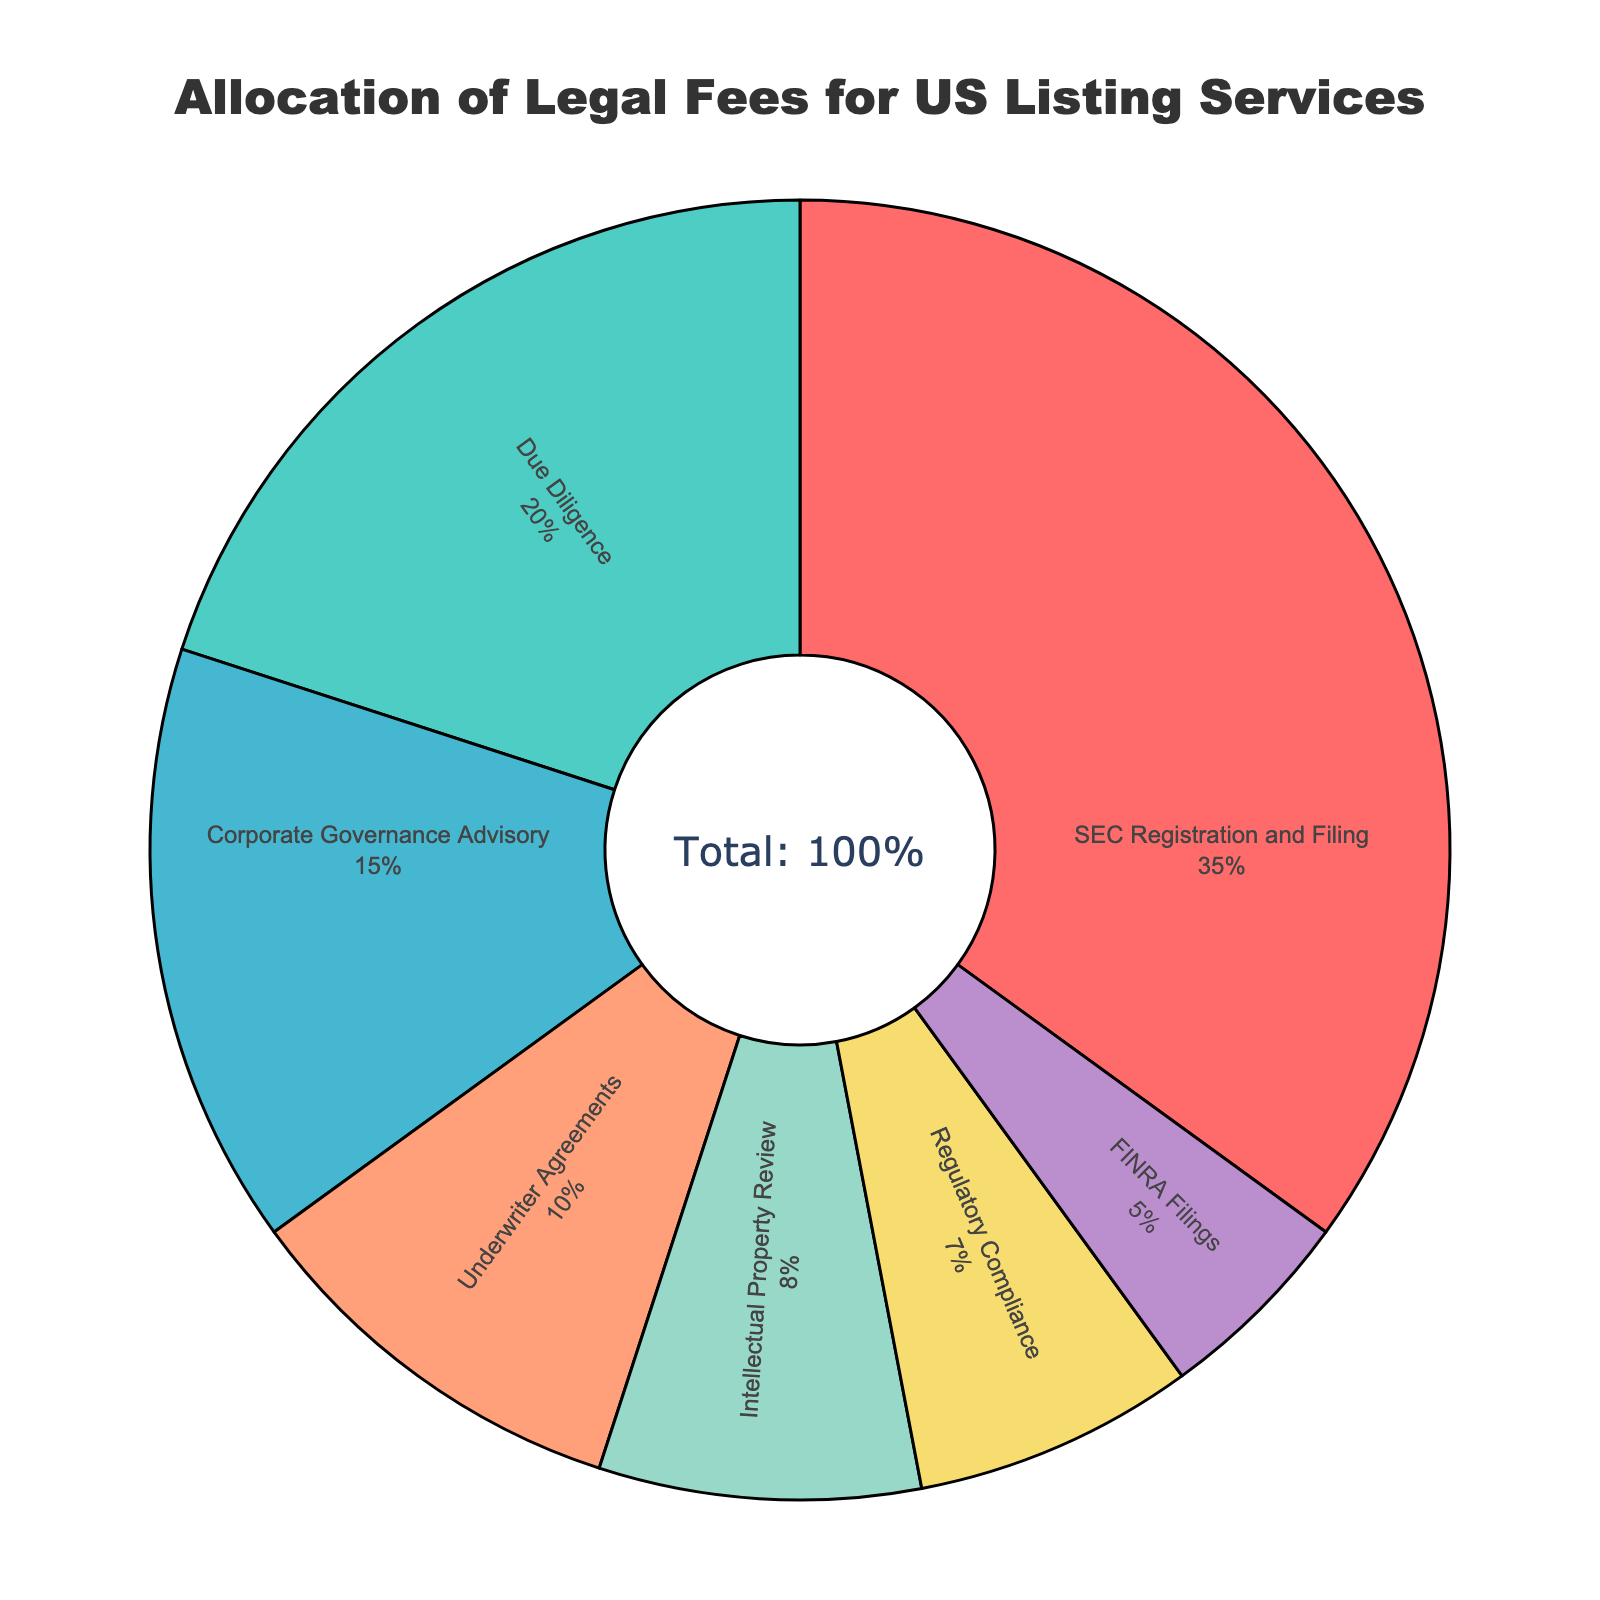What is the largest allocation percentage among the services? The largest allocation percentage can be found by looking at the segment that takes up the most space in the pie chart. In this case, it is labeled "SEC Registration and Filing" with a percentage of 35%.
Answer: 35% Which service has the smallest allocation, and what is its percentage? The smallest allocation percentage can be determined by finding the segment that takes up the least space. The slice labeled "FINRA Filings" has the smallest percentage of 5%.
Answer: FINRA Filings, 5% How much more is allocated to SEC Registration and Filing than to Regulatory Compliance? The allocation for SEC Registration and Filing is 35%, and for Regulatory Compliance, it is 7%. The difference is 35% - 7% = 28%.
Answer: 28% What is the total allocation percentage for Corporate Governance Advisory and Underwriter Agreements combined? The percentage allocations for Corporate Governance Advisory and Underwriter Agreements are 15% and 10%, respectively. Adding these together, we get 15% + 10% = 25%.
Answer: 25% Is the combined allocation for Due Diligence and Intellectual Property Review more or less than the allocation for SEC Registration and Filing? By how much? Due Diligence has an allocation of 20%, and Intellectual Property Review has 8%. Together, they total 20% + 8% = 28%. Compared to SEC Registration and Filing's 35%, this combined amount is less by 35% - 28% = 7%.
Answer: Less, by 7% What percentage of the total allocation is dedicated to Underwriter Agreements and FINRA Filings together? The allocation percentages for Underwriter Agreements and FINRA Filings are 10% and 5%, respectively. Together, they make up 10% + 5% = 15%.
Answer: 15% Which data point represents the green color segment, and what percentage does it have? According to the color scheme, the green color segment corresponds to Due Diligence. The percentage associated with this segment is 20%.
Answer: Due Diligence, 20% How does the allocation for Regulatory Compliance compare to that for Intellectual Property Review? The allocation for Regulatory Compliance is 7%, while for Intellectual Property Review, it is 8%. 7% is less than 8% by 1%.
Answer: Less by 1% What is the combined percentage allocation for all services except SEC Registration and Filing? Subtract the percentage for SEC Registration and Filing (35%) from the total (100%). The combined percentage allocation is 100% - 35% = 65%.
Answer: 65% What percentage of the total allocation is dedicated to services that are each allocated less than 10%? List those services as well. The services with less than 10% allocation are Intellectual Property Review (8%), Regulatory Compliance (7%), and FINRA Filings (5%). The combined percentage is 8% + 7% + 5% = 20%.
Answer: 20%, Intellectual Property Review, Regulatory Compliance, FINRA Filings 